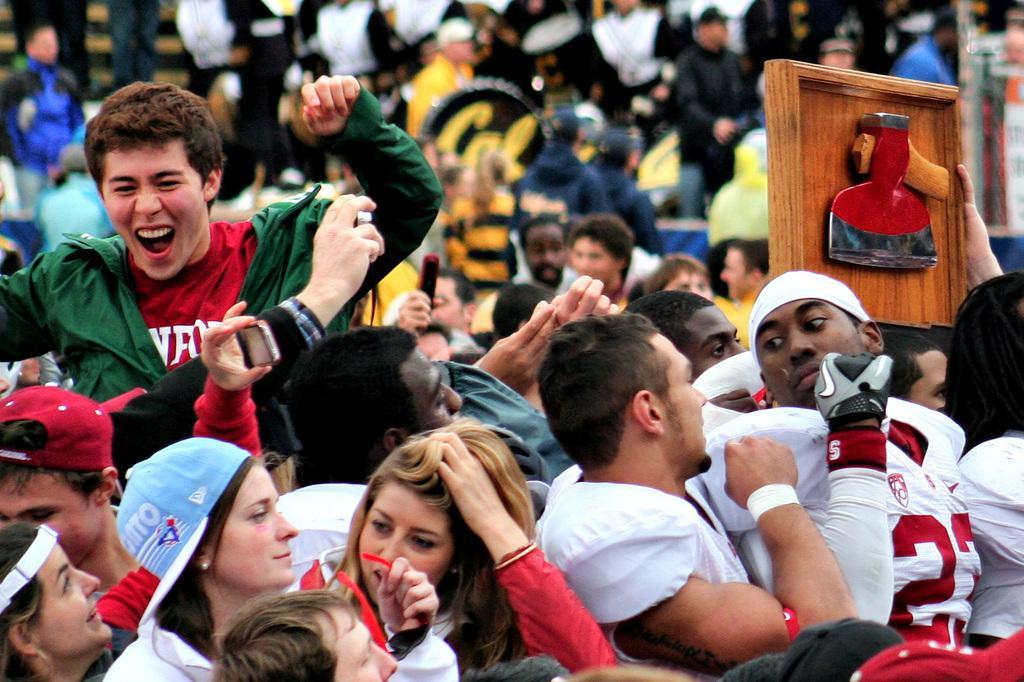Please provide a concise description of this image. In this image, we can see a few people. Among them, some people are holding objects. We can also see a wooden object. 